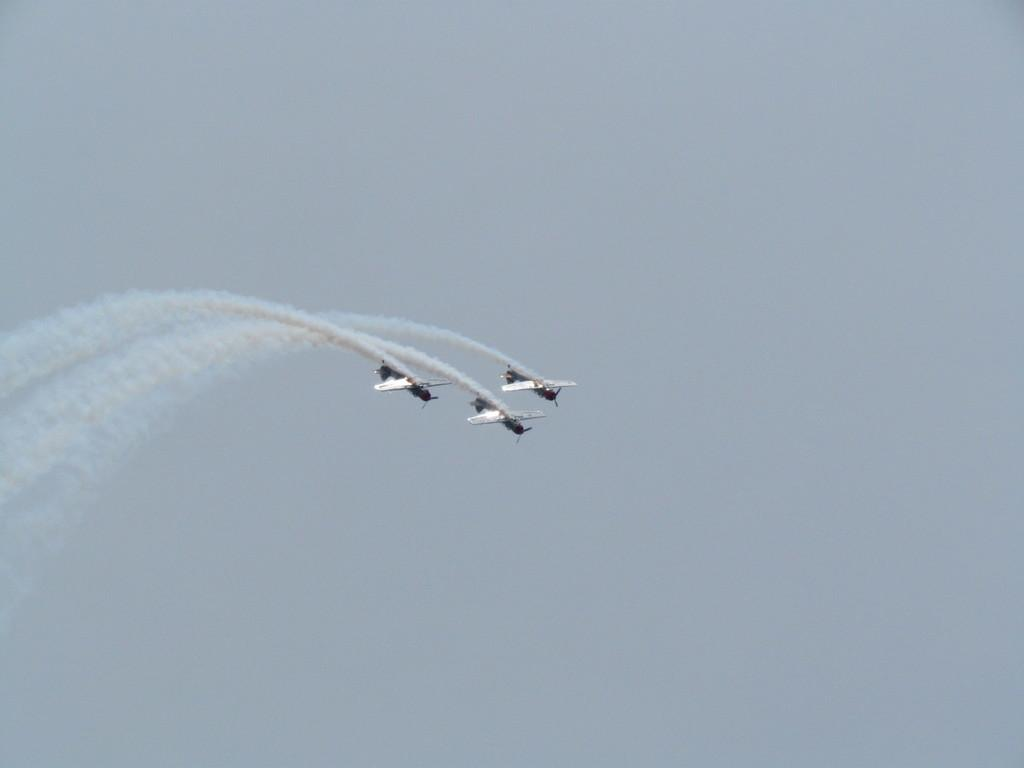What is happening in the sky in the image? There are three jets flying in the air, and they are releasing smoke. What type of smoke is being released by the jets? The smoke appears to be contrail. What can be seen in the background of the image? The sky is visible in the background. What type of popcorn can be seen being served in the wilderness by the governor in the image? There is no popcorn, wilderness, or governor present in the image. The image features three jets flying in the air and releasing smoke. 